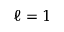<formula> <loc_0><loc_0><loc_500><loc_500>\ell = 1</formula> 